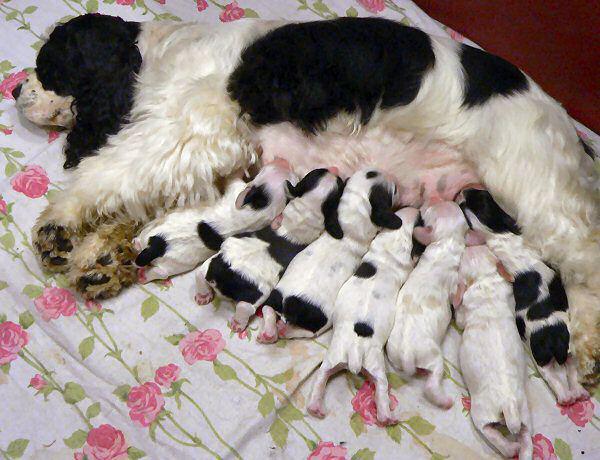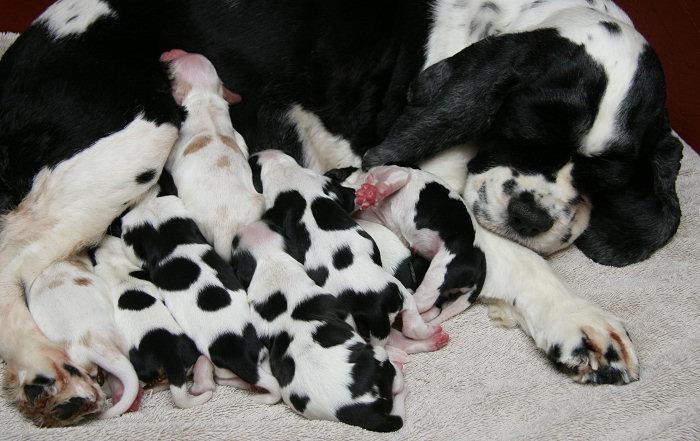The first image is the image on the left, the second image is the image on the right. For the images displayed, is the sentence "A litter of puppies is being fed by their mother." factually correct? Answer yes or no. Yes. The first image is the image on the left, the second image is the image on the right. For the images shown, is this caption "The right image contains no more than one dog." true? Answer yes or no. No. 